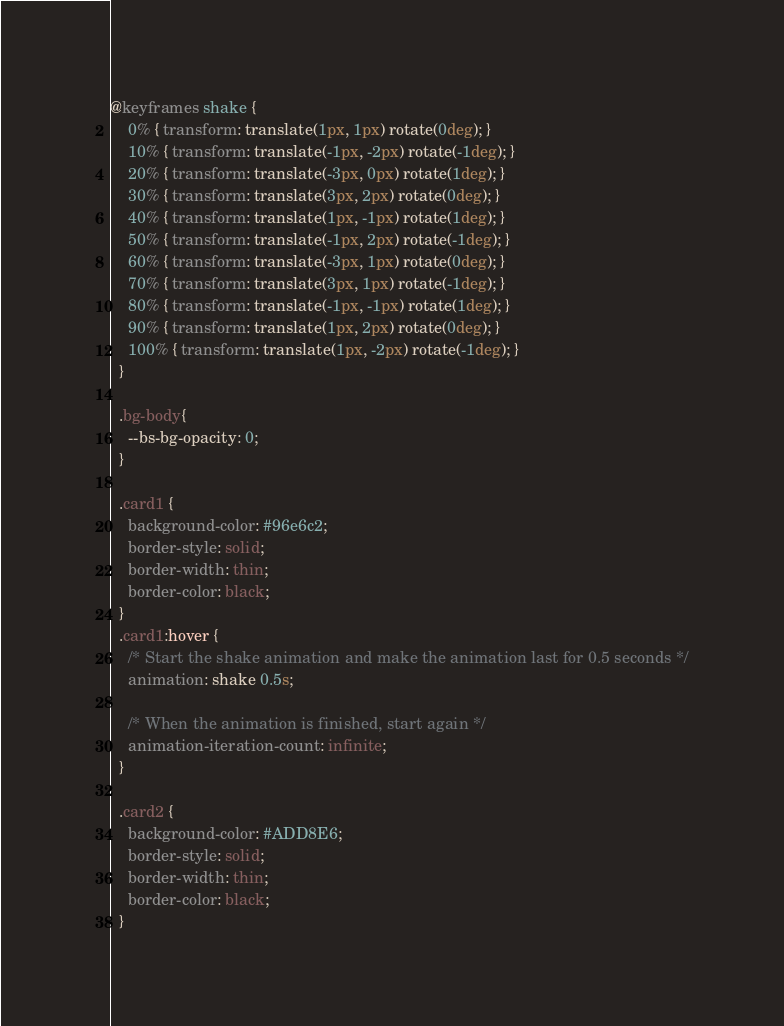Convert code to text. <code><loc_0><loc_0><loc_500><loc_500><_CSS_>
@keyframes shake {
    0% { transform: translate(1px, 1px) rotate(0deg); }
    10% { transform: translate(-1px, -2px) rotate(-1deg); }
    20% { transform: translate(-3px, 0px) rotate(1deg); }
    30% { transform: translate(3px, 2px) rotate(0deg); }
    40% { transform: translate(1px, -1px) rotate(1deg); }
    50% { transform: translate(-1px, 2px) rotate(-1deg); }
    60% { transform: translate(-3px, 1px) rotate(0deg); }
    70% { transform: translate(3px, 1px) rotate(-1deg); }
    80% { transform: translate(-1px, -1px) rotate(1deg); }
    90% { transform: translate(1px, 2px) rotate(0deg); }
    100% { transform: translate(1px, -2px) rotate(-1deg); }
  }

  .bg-body{
    --bs-bg-opacity: 0;
  }
  
  .card1 {
    background-color: #96e6c2;
    border-style: solid;
    border-width: thin;
    border-color: black;
  }
  .card1:hover {
    /* Start the shake animation and make the animation last for 0.5 seconds */
    animation: shake 0.5s;
  
    /* When the animation is finished, start again */
    animation-iteration-count: infinite;
  }
  
  .card2 {
    background-color: #ADD8E6;
    border-style: solid;
    border-width: thin;
    border-color: black;
  }</code> 